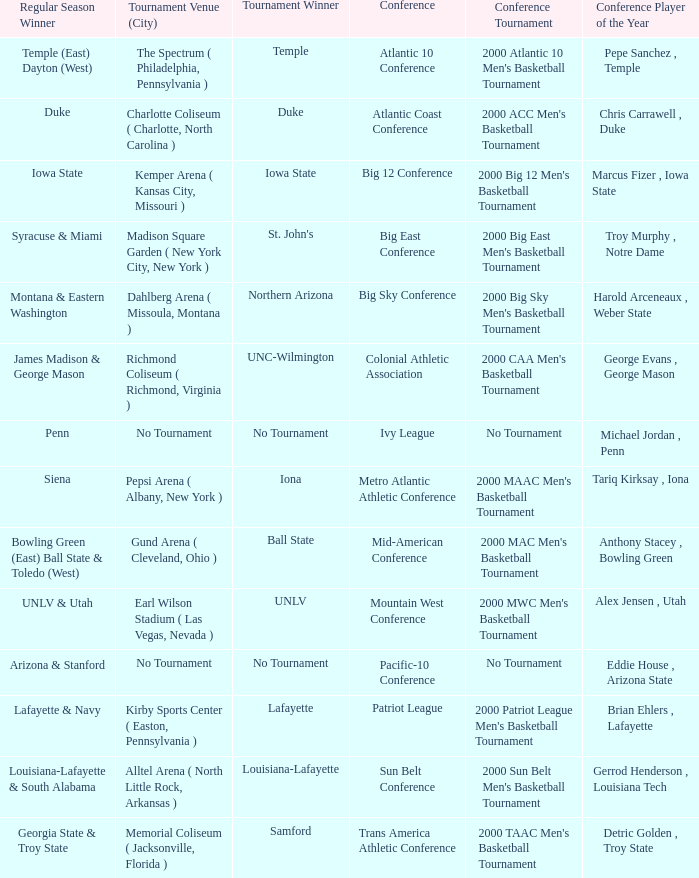What is the venue and city where the 2000 MWC Men's Basketball Tournament? Earl Wilson Stadium ( Las Vegas, Nevada ). 